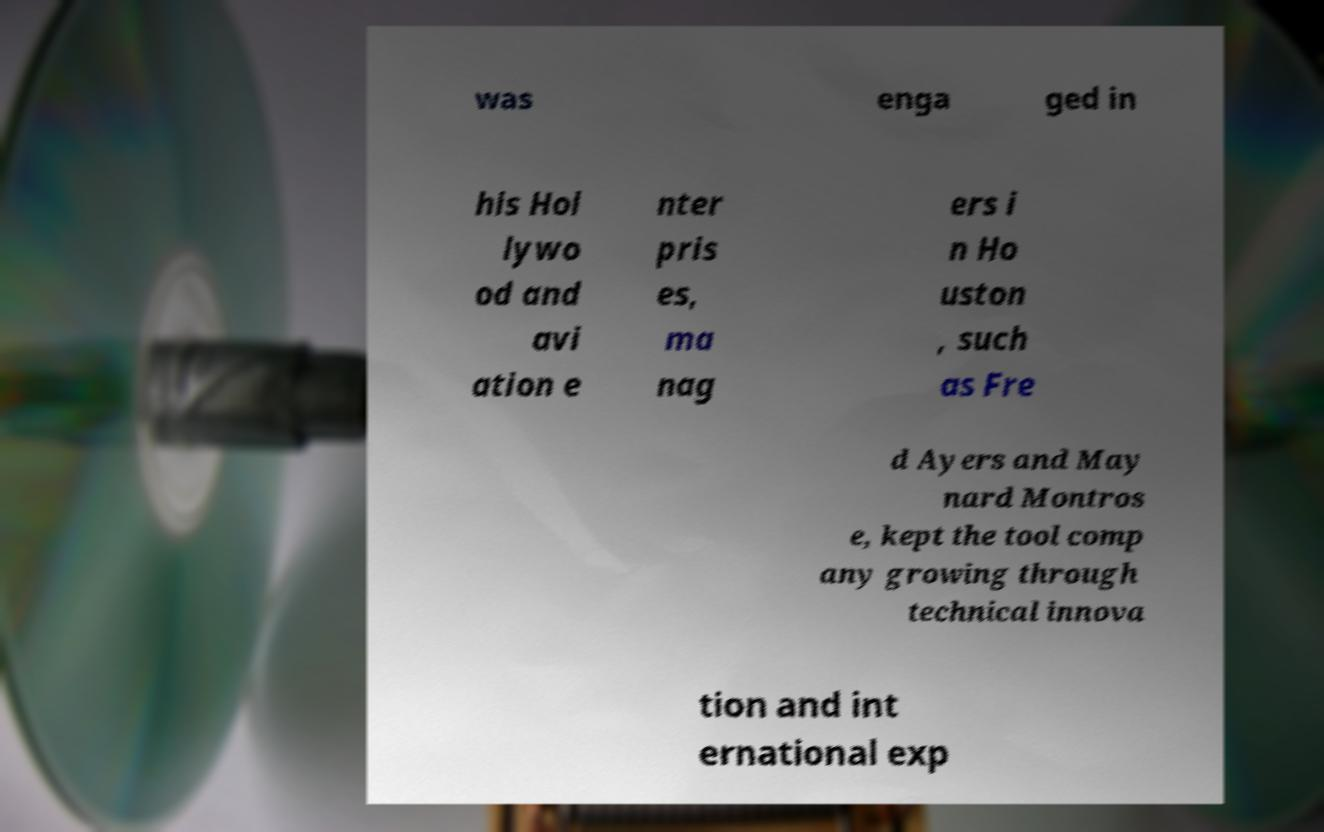There's text embedded in this image that I need extracted. Can you transcribe it verbatim? was enga ged in his Hol lywo od and avi ation e nter pris es, ma nag ers i n Ho uston , such as Fre d Ayers and May nard Montros e, kept the tool comp any growing through technical innova tion and int ernational exp 